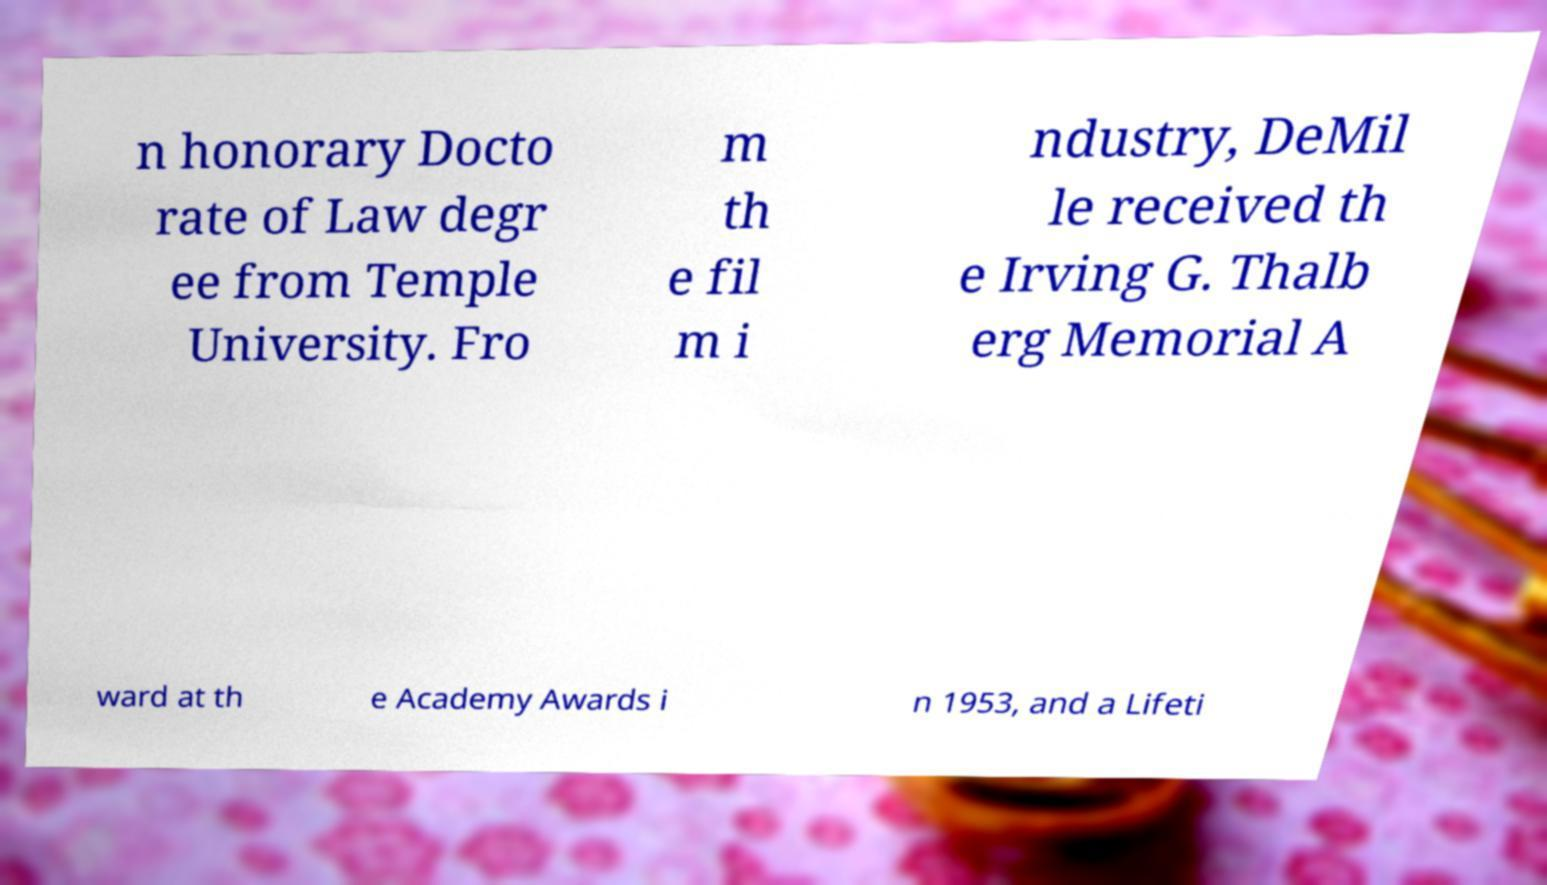I need the written content from this picture converted into text. Can you do that? n honorary Docto rate of Law degr ee from Temple University. Fro m th e fil m i ndustry, DeMil le received th e Irving G. Thalb erg Memorial A ward at th e Academy Awards i n 1953, and a Lifeti 